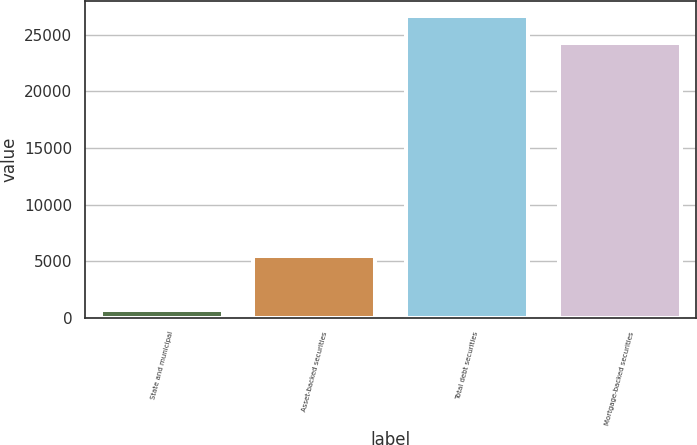Convert chart. <chart><loc_0><loc_0><loc_500><loc_500><bar_chart><fcel>State and municipal<fcel>Asset-backed securities<fcel>Total debt securities<fcel>Mortgage-backed securities<nl><fcel>713<fcel>5460<fcel>26626.2<fcel>24236<nl></chart> 